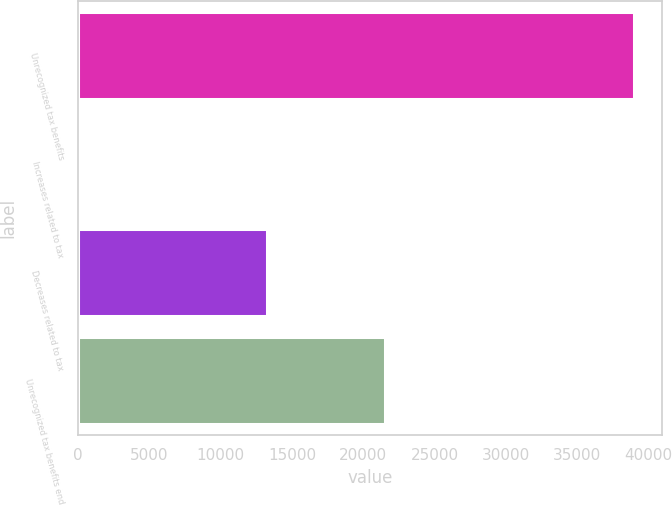Convert chart. <chart><loc_0><loc_0><loc_500><loc_500><bar_chart><fcel>Unrecognized tax benefits<fcel>Increases related to tax<fcel>Decreases related to tax<fcel>Unrecognized tax benefits end<nl><fcel>38992<fcel>114<fcel>13218<fcel>21502<nl></chart> 